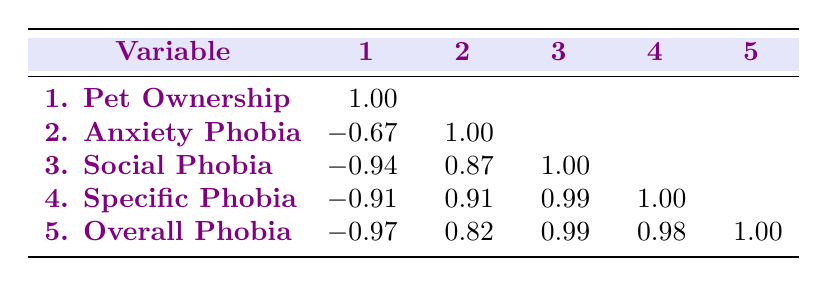What is the pet ownership rate in urban areas? The table indicates the pet ownership rate for urban areas is specifically listed under the "Pet Ownership" row for urban settings, which is 65.
Answer: 65 What is the incidence of social phobia in rural areas? By looking at the table, under the "Social Phobia" row for rural settings, the incidence is recorded as 10.
Answer: 10 Does a higher pet ownership rate correlate with a higher incidence of overall phobia? Observing the correlation values, the pet ownership rate has a negative correlation of -0.97 with overall phobia incidence, suggesting a higher pet ownership rate is linked to a lower incidence of overall phobia.
Answer: Yes What is the difference in anxiety phobia incidence between urban and rural areas? The anxiety phobia incidence for urban areas is 30, while for rural areas it's 20. To find the difference, subtract: 30 - 20 = 10.
Answer: 10 Is it true that specific phobia incidence is higher in urban areas compared to rural areas? The table shows that the specific phobia incidence for urban is 15 and for rural is 5. Thus, the specific phobia incidence in urban areas is higher than in rural areas, which confirms the statement is true.
Answer: Yes What is the average incidence of fear of heights in urban areas compared to rural areas? The fear of heights incidence for urban is 18 and for rural is 8. To find the average, add both values (18 + 8 = 26) and divide by the number of values, which is 2: 26/2 = 13.
Answer: 13 What is the pet ownership rate formula derived from the overall phobia incidence? While there isn't a direct formula derived from the table, the negative correlations suggest that as pet ownership increases, overall phobia incidence decreases. The table shows a correlation of -0.97 with overall phobia, indicating a strong negative relationship. Thus, pet ownership does seem to relate to lower phobia incidence.
Answer: Strong negative relationship Which location has a lower incidence of fear of snakes, urban or rural? By checking the table, the fear of snakes incidence is 20 for urban areas and 10 for rural areas. Therefore, rural areas have a lower incidence of fear of snakes.
Answer: Rural areas What can be inferred about dog ownership rates in urban versus rural locations? The table shows dog ownership rates: urban is 40 and rural is 65. Therefore, we can infer that rural locations have higher dog ownership rates than urban locations.
Answer: Higher in rural locations 